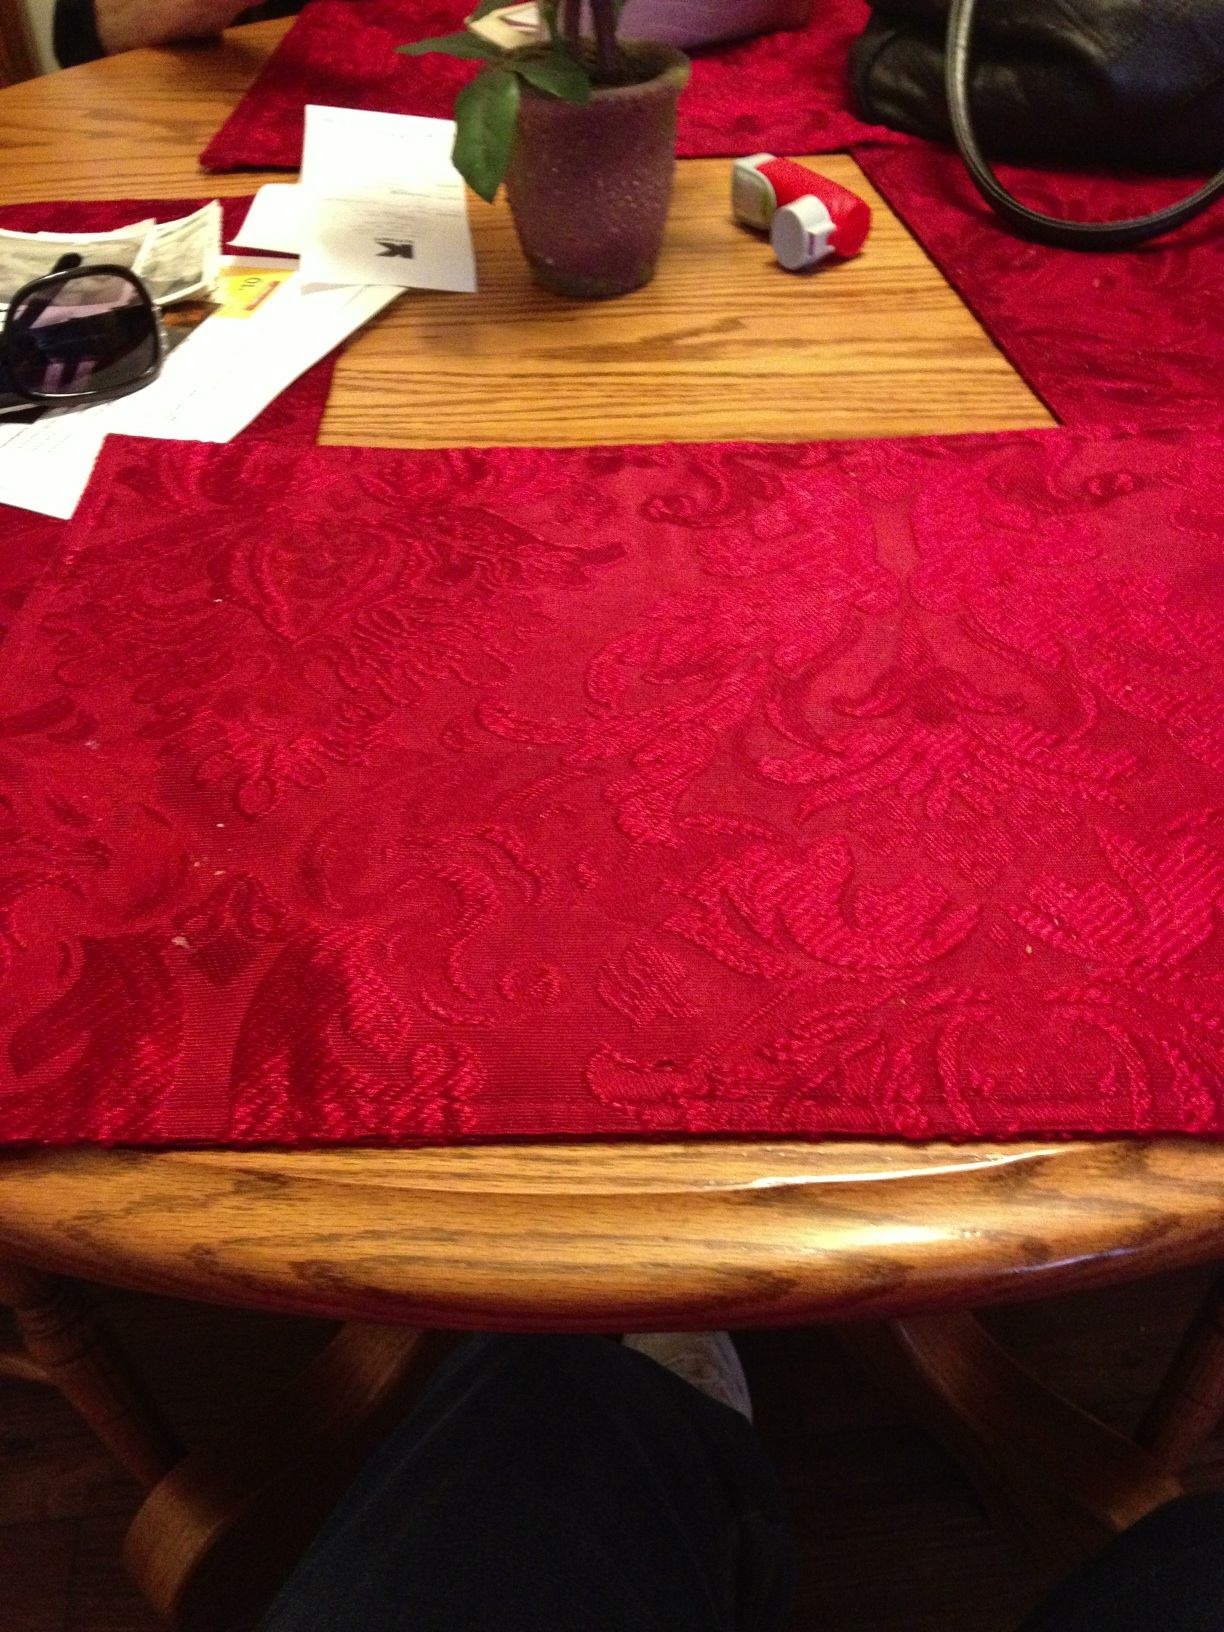What color is the mat? from Vizwiz red 